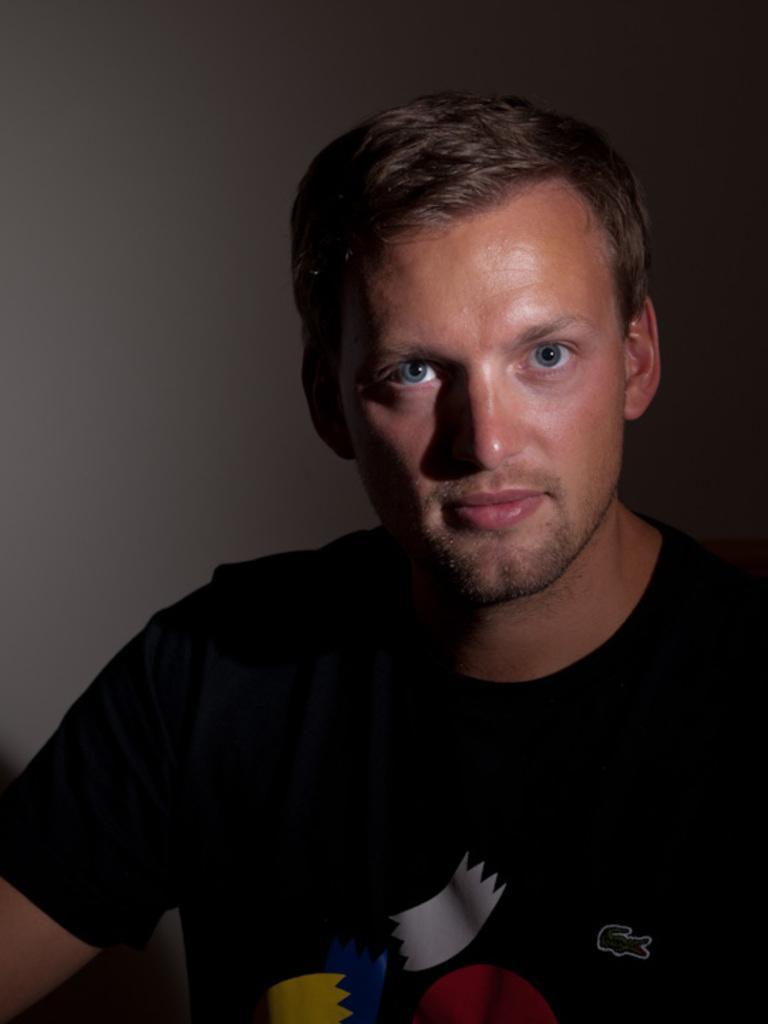In one or two sentences, can you explain what this image depicts? In this picture there is a person wearing black t-shirt. In the background it is well. 